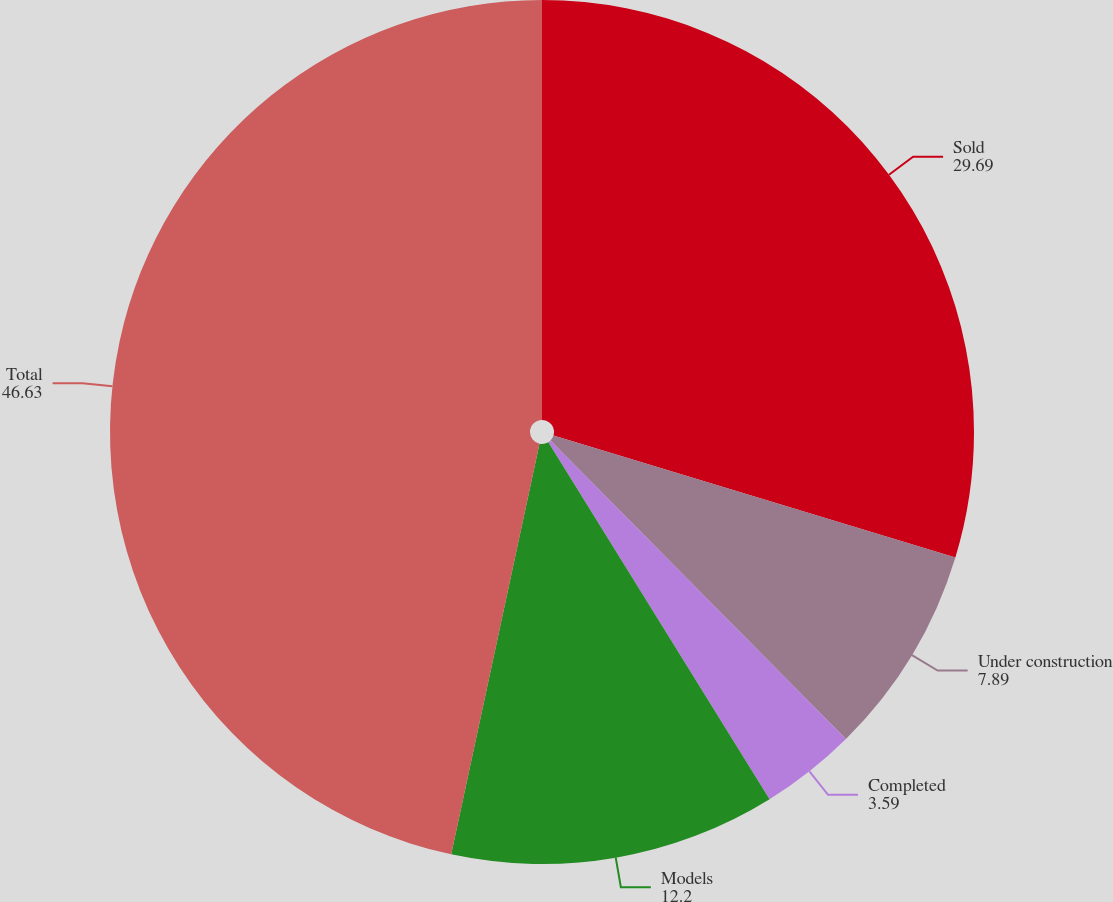Convert chart. <chart><loc_0><loc_0><loc_500><loc_500><pie_chart><fcel>Sold<fcel>Under construction<fcel>Completed<fcel>Models<fcel>Total<nl><fcel>29.69%<fcel>7.89%<fcel>3.59%<fcel>12.2%<fcel>46.63%<nl></chart> 